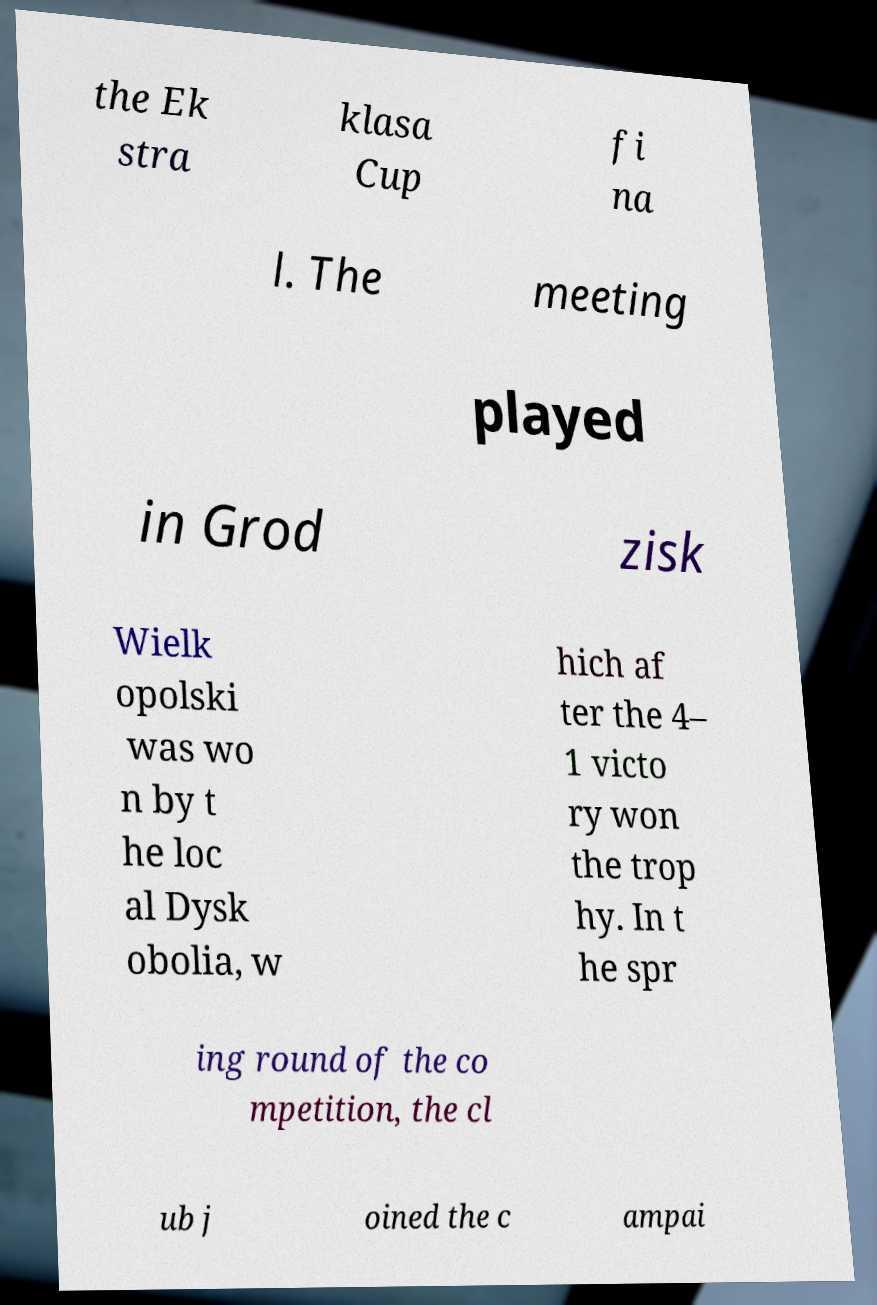For documentation purposes, I need the text within this image transcribed. Could you provide that? the Ek stra klasa Cup fi na l. The meeting played in Grod zisk Wielk opolski was wo n by t he loc al Dysk obolia, w hich af ter the 4– 1 victo ry won the trop hy. In t he spr ing round of the co mpetition, the cl ub j oined the c ampai 